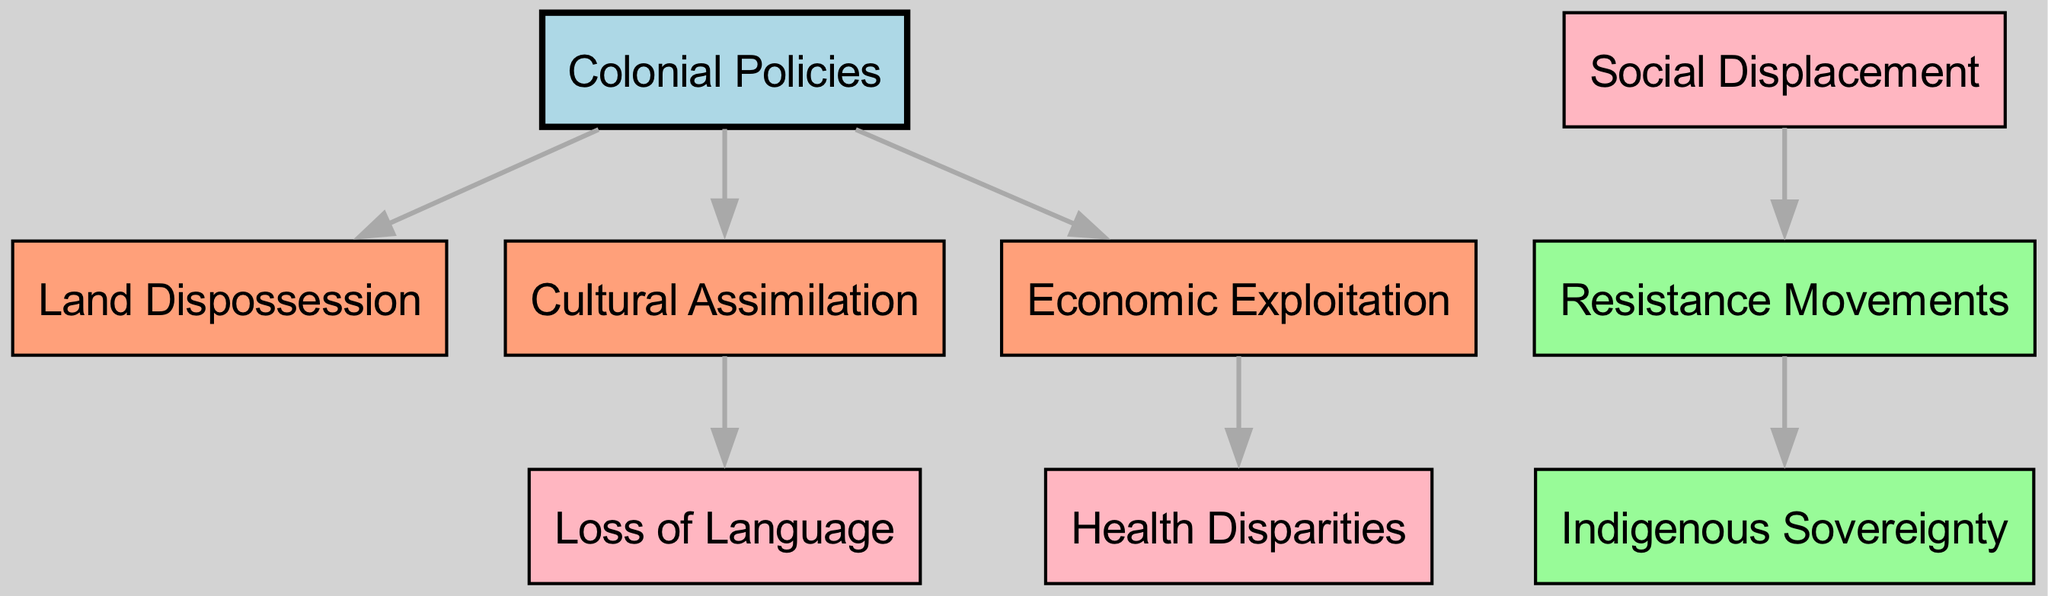What is the total number of nodes in the diagram? The diagram presents multiple nodes, each representing a concept. By visually counting the boxes, we find there are 9 unique nodes in total.
Answer: 9 What are the nodes connected directly to "Colonial Policies"? Analyzing the edges from "Colonial Policies," we see direct connections to three nodes: "Land Dispossession," "Cultural Assimilation," and "Economic Exploitation."
Answer: Land Dispossession, Cultural Assimilation, Economic Exploitation Which node is connected to "Cultural Assimilation"? The diagram shows an outward edge from "Cultural Assimilation" leading to the node "Loss of Language," indicating a direct relationship.
Answer: Loss of Language How many edges are leading out from "Economic Exploitation"? The analysis of the edges from "Economic Exploitation" reveals that there is one outgoing edge connected to "Health Disparities."
Answer: 1 What is the final node that is reached through "Resistance Movements"? Following the edge from "Resistance Movements," we find it connects to "Indigenous Sovereignty," which is the final node in that pathway.
Answer: Indigenous Sovereignty What happens as a result of "Social Displacement"? The diagram indicates that "Social Displacement" leads directly to "Resistance Movements," implying that as societies are displaced, resistance organizes.
Answer: Resistance Movements What color represents "Colonial Policies" in the diagram? Observing the diagram, "Colonial Policies" is highlighted in light blue, distinguishing it from other nodes with different colors.
Answer: Light blue How many nodes indicate negative impacts such as "Health Disparities" and "Loss of Language"? Counting the nodes that reflect adverse effects, we identify four nodes: "Health Disparities," "Loss of Language," "Social Displacement," and another associated directly with "Economic Exploitation."
Answer: 4 Which node represents economic consequences stemming from "Colonial Policies"? The edge traced from "Colonial Policies" directs us to "Economic Exploitation," indicating that economic disadvantages arise from these policies.
Answer: Economic Exploitation 